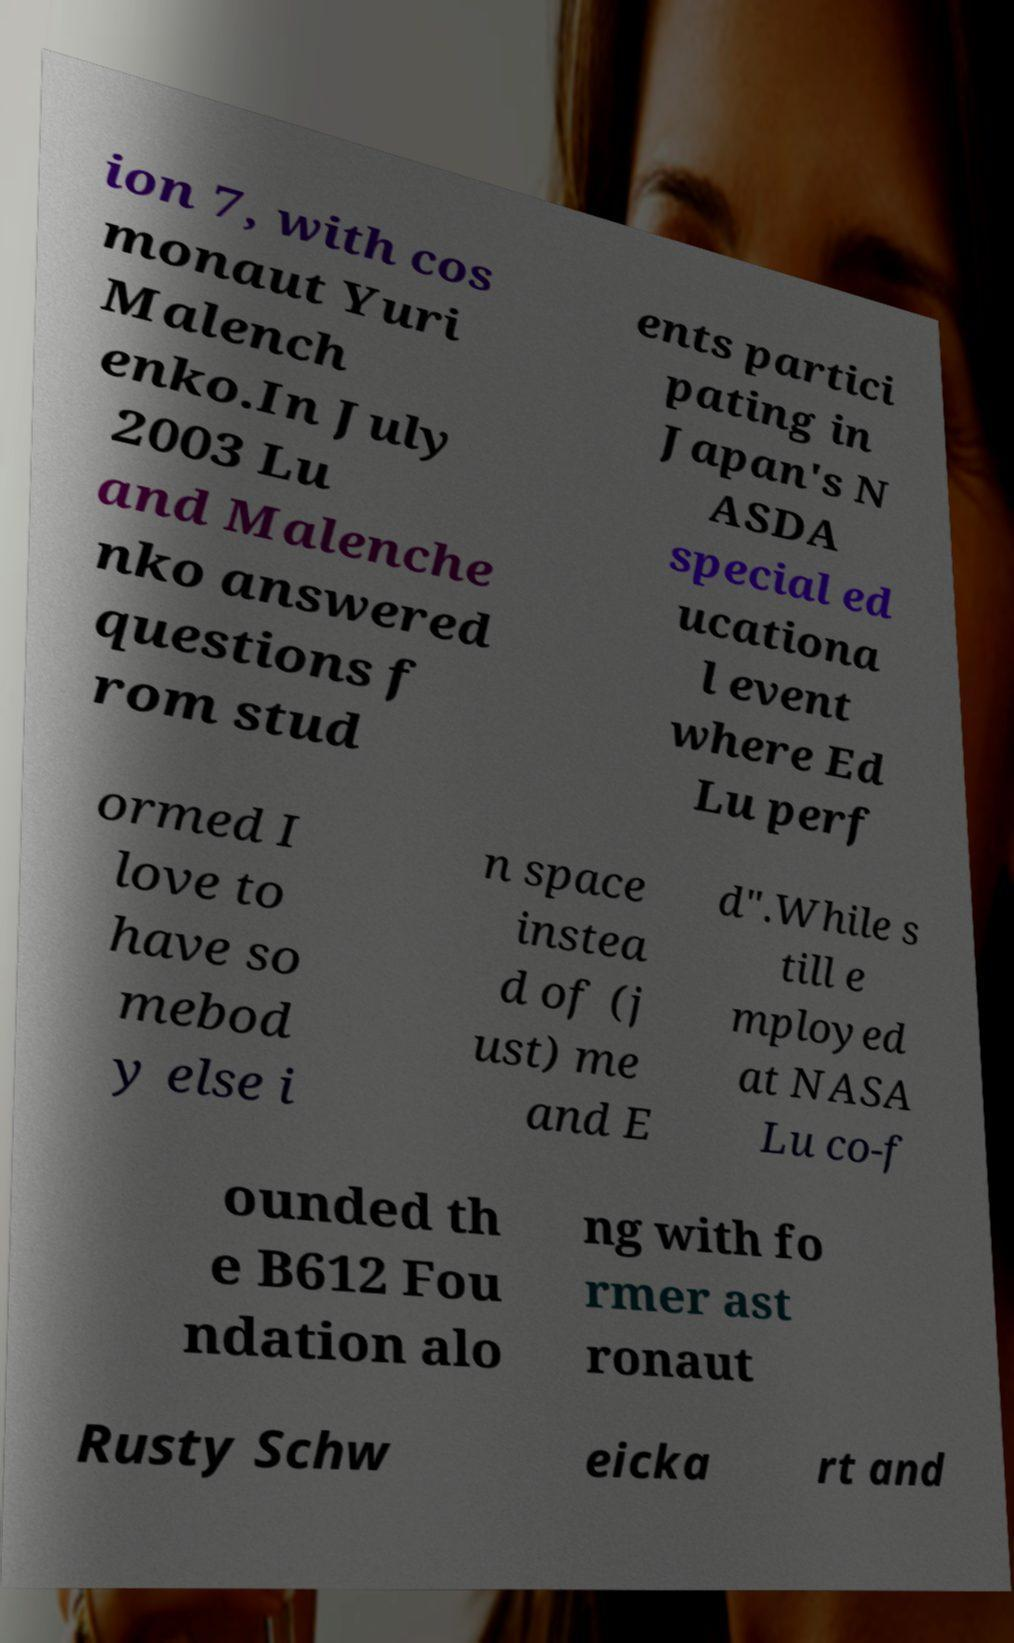What messages or text are displayed in this image? I need them in a readable, typed format. ion 7, with cos monaut Yuri Malench enko.In July 2003 Lu and Malenche nko answered questions f rom stud ents partici pating in Japan's N ASDA special ed ucationa l event where Ed Lu perf ormed I love to have so mebod y else i n space instea d of (j ust) me and E d".While s till e mployed at NASA Lu co-f ounded th e B612 Fou ndation alo ng with fo rmer ast ronaut Rusty Schw eicka rt and 